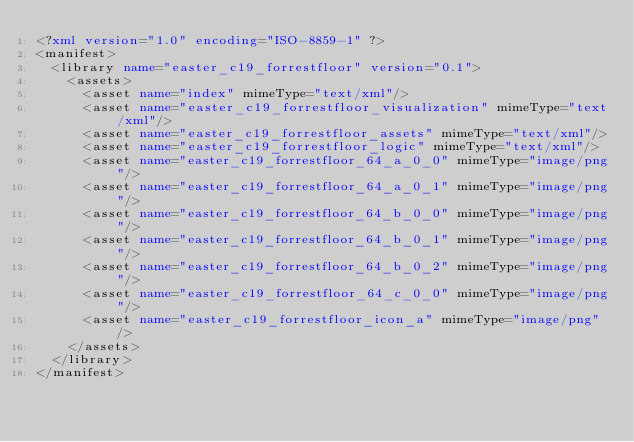<code> <loc_0><loc_0><loc_500><loc_500><_XML_><?xml version="1.0" encoding="ISO-8859-1" ?><manifest>
  <library name="easter_c19_forrestfloor" version="0.1">
    <assets>
      <asset name="index" mimeType="text/xml"/>
      <asset name="easter_c19_forrestfloor_visualization" mimeType="text/xml"/>
      <asset name="easter_c19_forrestfloor_assets" mimeType="text/xml"/>
      <asset name="easter_c19_forrestfloor_logic" mimeType="text/xml"/>
      <asset name="easter_c19_forrestfloor_64_a_0_0" mimeType="image/png"/>
      <asset name="easter_c19_forrestfloor_64_a_0_1" mimeType="image/png"/>
      <asset name="easter_c19_forrestfloor_64_b_0_0" mimeType="image/png"/>
      <asset name="easter_c19_forrestfloor_64_b_0_1" mimeType="image/png"/>
      <asset name="easter_c19_forrestfloor_64_b_0_2" mimeType="image/png"/>
      <asset name="easter_c19_forrestfloor_64_c_0_0" mimeType="image/png"/>
      <asset name="easter_c19_forrestfloor_icon_a" mimeType="image/png"/>
    </assets>
  </library>
</manifest></code> 